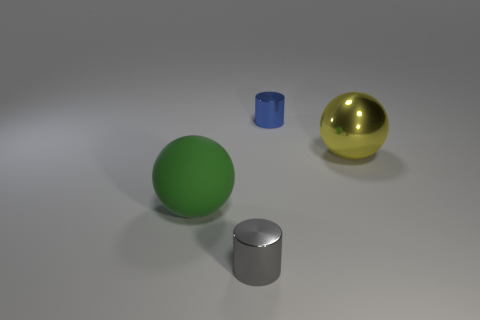How many spheres are green rubber things or blue shiny objects?
Offer a terse response. 1. There is a sphere that is the same material as the gray object; what size is it?
Offer a terse response. Large. How many other matte balls are the same color as the large matte sphere?
Give a very brief answer. 0. Are there any shiny cylinders in front of the big green matte sphere?
Make the answer very short. Yes. There is a large yellow metal thing; is its shape the same as the large object to the left of the gray thing?
Your answer should be compact. Yes. What number of things are big things that are right of the big green ball or small metallic cylinders?
Provide a short and direct response. 3. Are there any other things that are made of the same material as the green sphere?
Your response must be concise. No. How many things are right of the green thing and behind the gray thing?
Your answer should be compact. 2. What number of things are either small things behind the metal ball or small cylinders behind the gray shiny cylinder?
Make the answer very short. 1. How many other things are the same shape as the tiny blue metal object?
Make the answer very short. 1. 